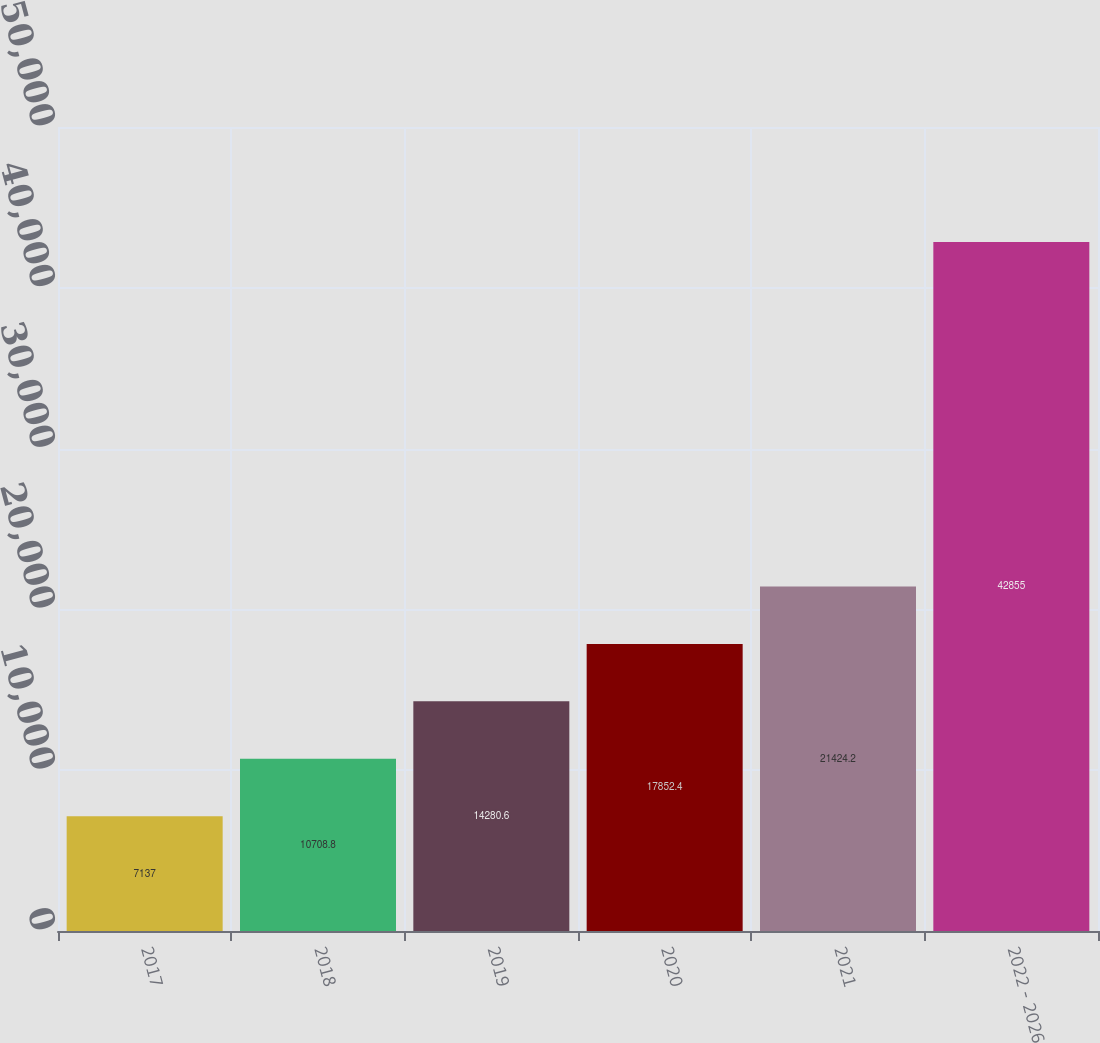Convert chart. <chart><loc_0><loc_0><loc_500><loc_500><bar_chart><fcel>2017<fcel>2018<fcel>2019<fcel>2020<fcel>2021<fcel>2022 - 2026<nl><fcel>7137<fcel>10708.8<fcel>14280.6<fcel>17852.4<fcel>21424.2<fcel>42855<nl></chart> 